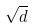<formula> <loc_0><loc_0><loc_500><loc_500>\sqrt { d }</formula> 